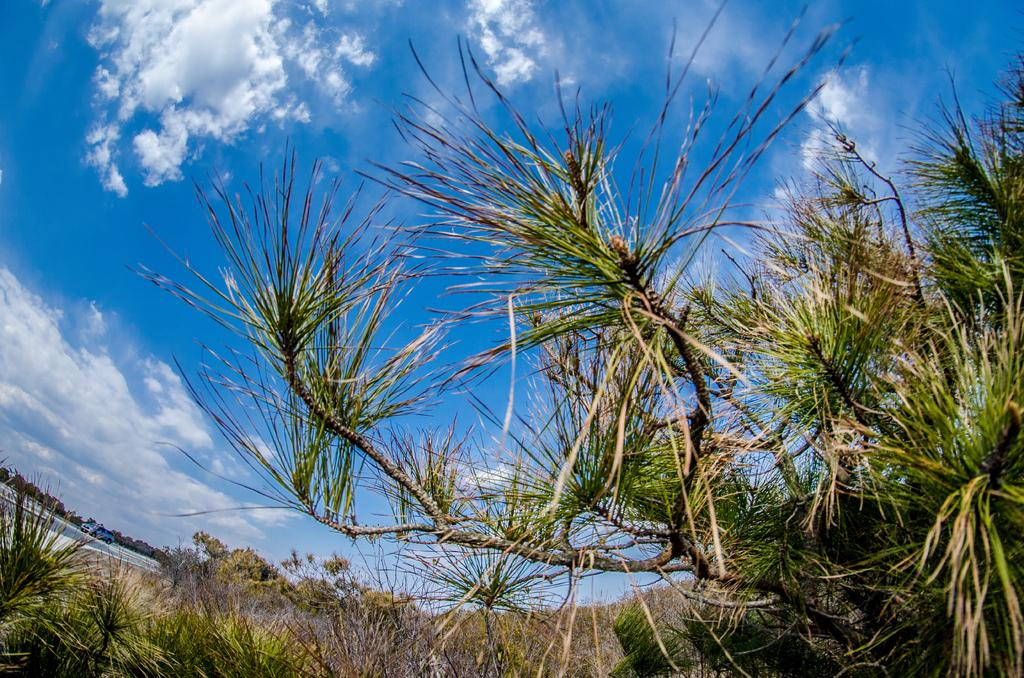What type of natural elements can be seen in the image? There are trees and plants visible in the image. What can be seen in the sky in the image? There are clouds visible in the image. Where is the car located in the image? The car is on the left side of the image, presumably on a road. What type of flesh can be seen on the trees in the image? There is no flesh present on the trees in the image; they are made of wood and leaves. Can you hear any music playing in the image? There is no indication of music or any sound in the image, as it is a still photograph. 